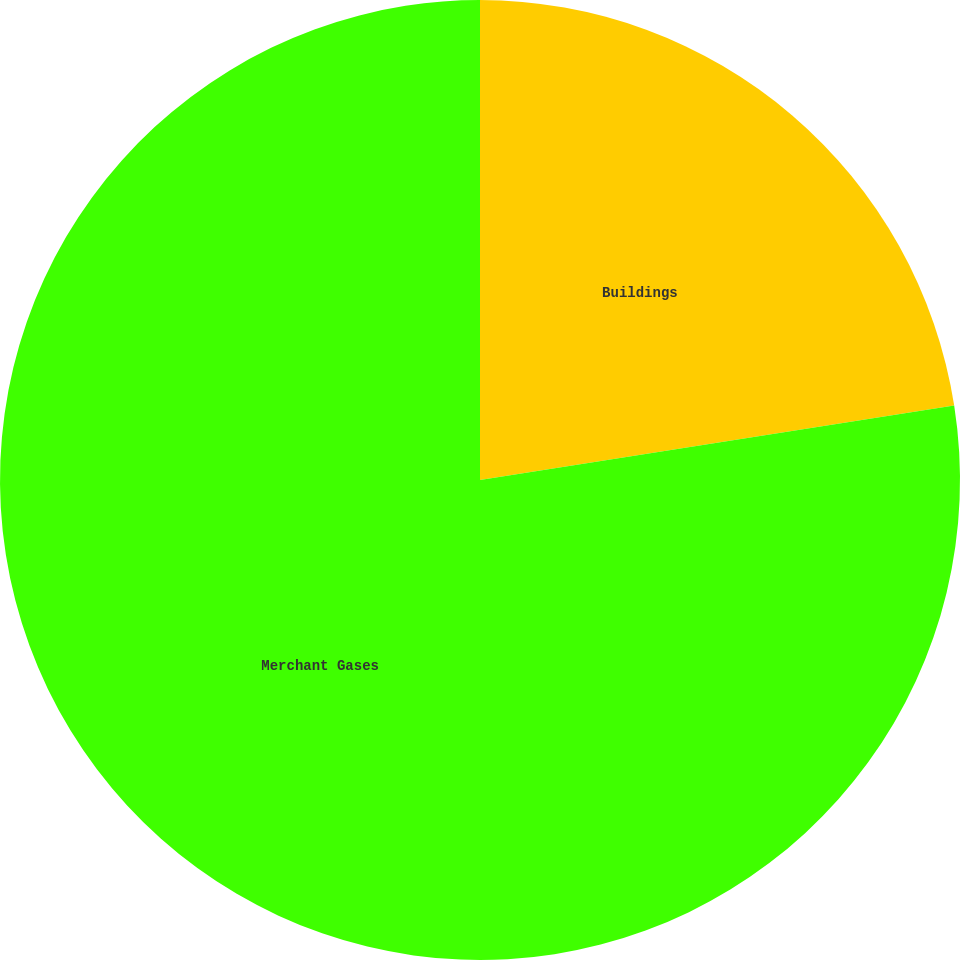Convert chart. <chart><loc_0><loc_0><loc_500><loc_500><pie_chart><fcel>Buildings<fcel>Merchant Gases<nl><fcel>22.52%<fcel>77.48%<nl></chart> 